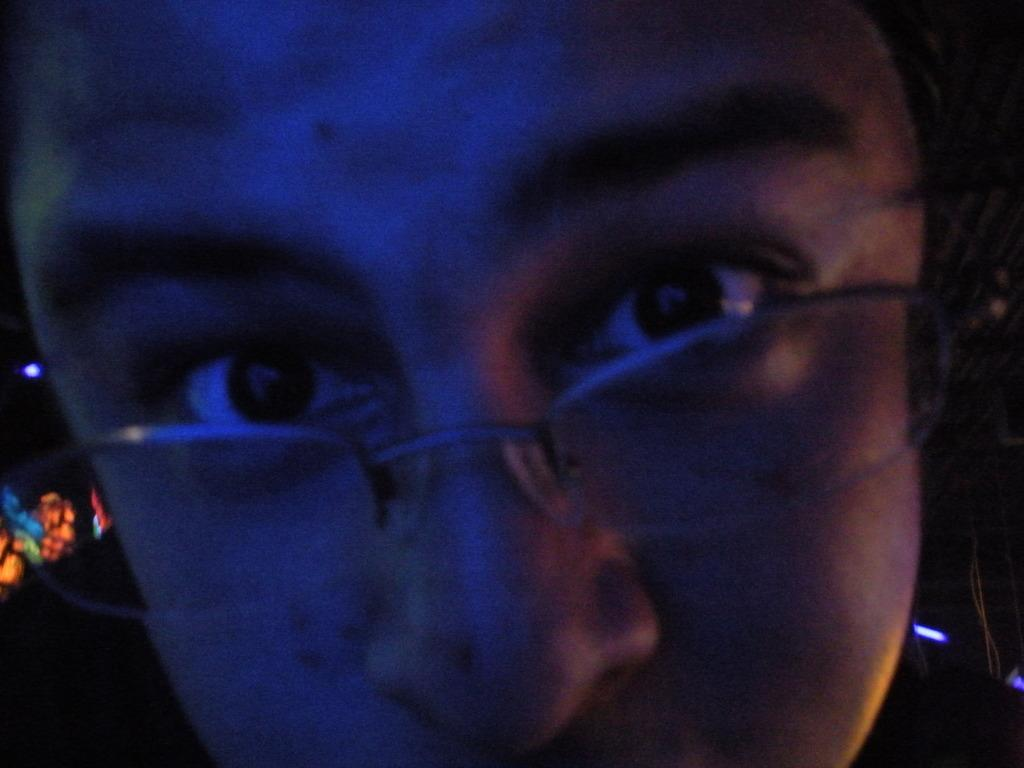What is the main subject of the image? The main subject of the image is a person. Can you describe any specific features or accessories the person is wearing? Yes, the person is wearing spectacles on their face. How many horses can be seen grazing in the background of the image? There are no horses present in the image. What day of the week is it in the image? The day of the week is not visible or mentioned in the image. 